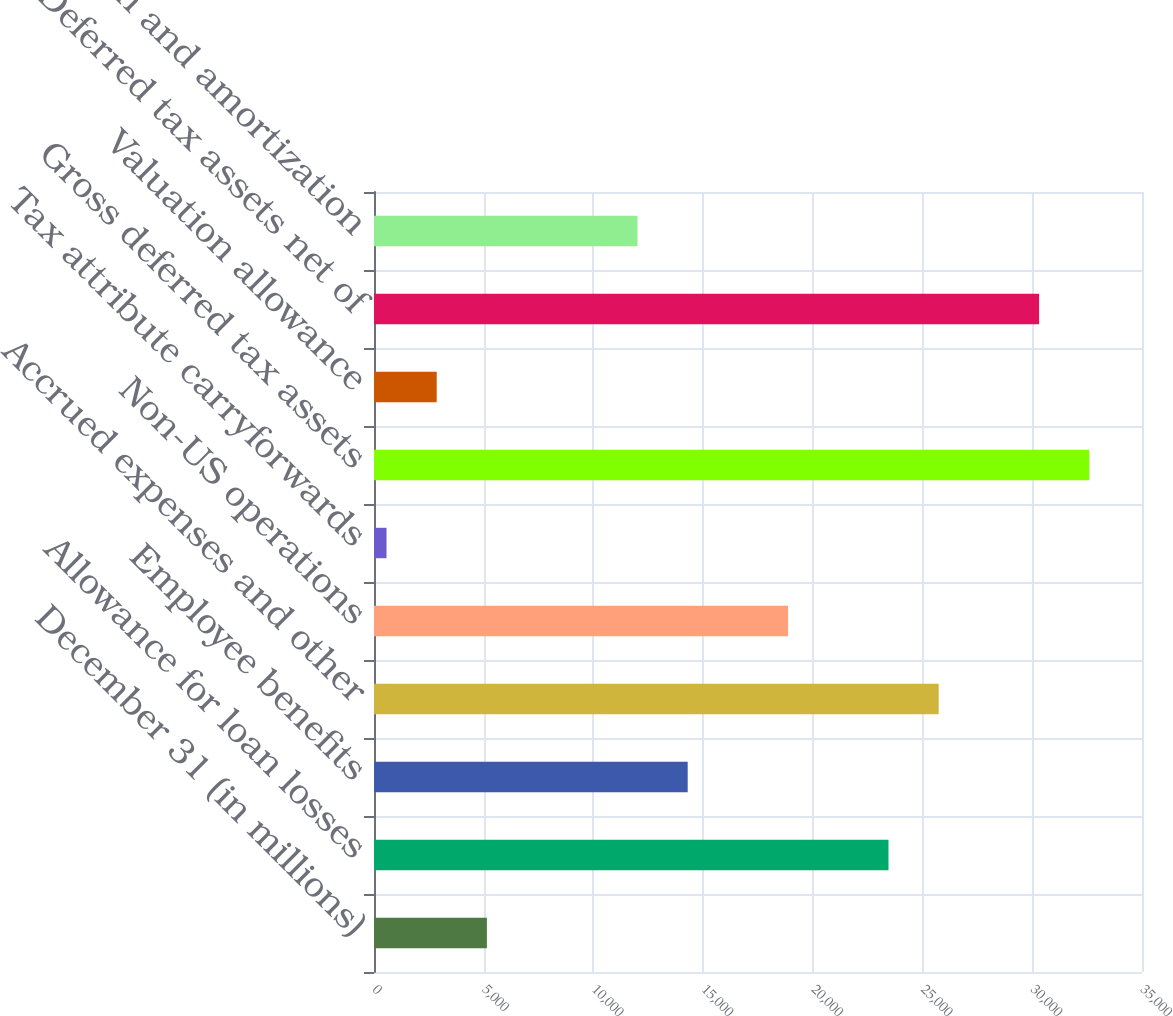<chart> <loc_0><loc_0><loc_500><loc_500><bar_chart><fcel>December 31 (in millions)<fcel>Allowance for loan losses<fcel>Employee benefits<fcel>Accrued expenses and other<fcel>Non-US operations<fcel>Tax attribute carryforwards<fcel>Gross deferred tax assets<fcel>Valuation allowance<fcel>Deferred tax assets net of<fcel>Depreciation and amortization<nl><fcel>5145.4<fcel>23447<fcel>14296.2<fcel>25734.7<fcel>18871.6<fcel>570<fcel>32597.8<fcel>2857.7<fcel>30310.1<fcel>12008.5<nl></chart> 